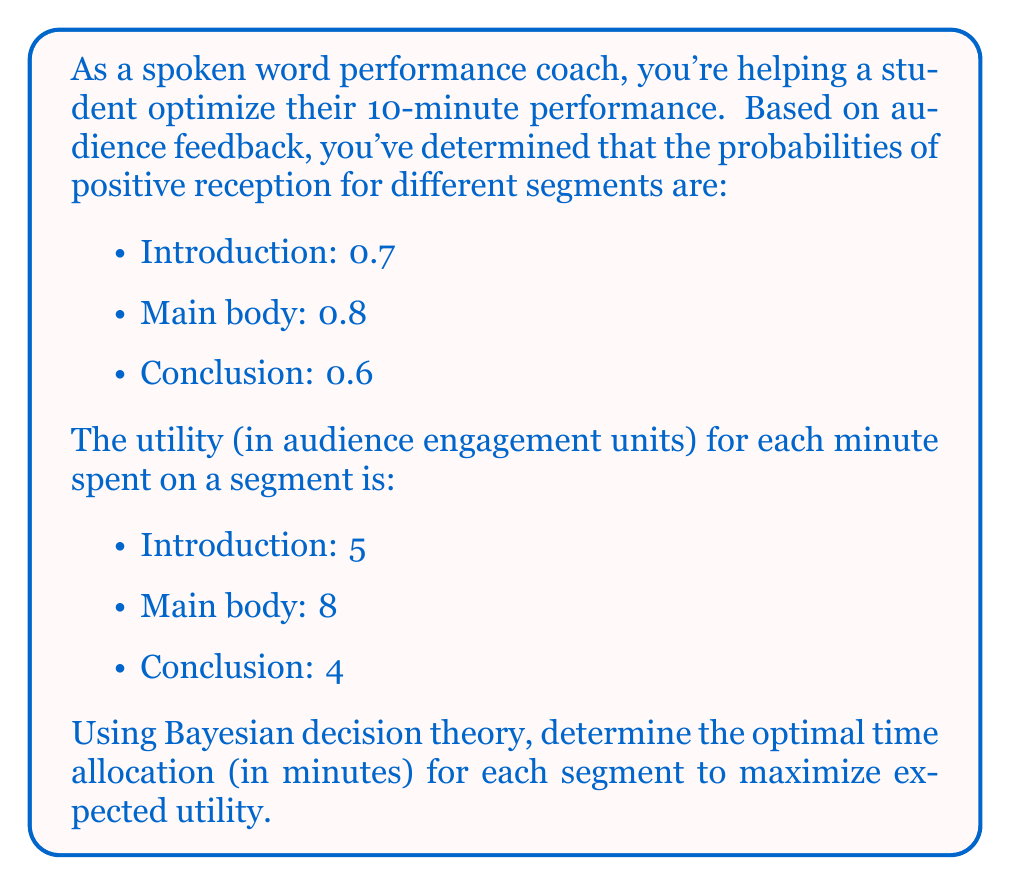Solve this math problem. To solve this problem using Bayesian decision theory, we need to maximize the expected utility for the entire performance. Let's approach this step-by-step:

1) Let $x$, $y$, and $z$ represent the time (in minutes) allocated to the introduction, main body, and conclusion, respectively.

2) The constraint equation is:
   
   $x + y + z = 10$

3) The expected utility for each segment is the product of its probability, utility per minute, and time allocated:

   Introduction: $0.7 \cdot 5 \cdot x = 3.5x$
   Main body: $0.8 \cdot 8 \cdot y = 6.4y$
   Conclusion: $0.6 \cdot 4 \cdot z = 2.4z$

4) The total expected utility function is:

   $E(U) = 3.5x + 6.4y + 2.4z$

5) We need to maximize this function subject to the constraint $x + y + z = 10$.

6) Using the method of Lagrange multipliers:

   $L(x, y, z, \lambda) = 3.5x + 6.4y + 2.4z - \lambda(x + y + z - 10)$

7) Taking partial derivatives and setting them to zero:

   $\frac{\partial L}{\partial x} = 3.5 - \lambda = 0$
   $\frac{\partial L}{\partial y} = 6.4 - \lambda = 0$
   $\frac{\partial L}{\partial z} = 2.4 - \lambda = 0$
   $\frac{\partial L}{\partial \lambda} = x + y + z - 10 = 0$

8) From these equations, we can see that $\lambda = 6.4$, which means the optimal solution allocates time only to the main body (y).

9) Therefore, the optimal allocation is:
   $x = 0$, $y = 10$, $z = 0$

This means the entire 10 minutes should be allocated to the main body of the performance to maximize expected utility.
Answer: The optimal time allocation is:
Introduction: 0 minutes
Main body: 10 minutes
Conclusion: 0 minutes 